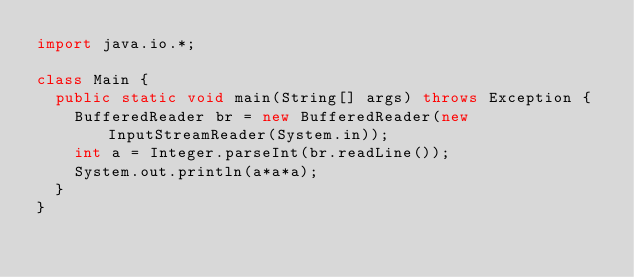Convert code to text. <code><loc_0><loc_0><loc_500><loc_500><_Java_>import java.io.*;

class Main {
	public static void main(String[] args) throws Exception {
		BufferedReader br = new BufferedReader(new InputStreamReader(System.in));
		int a = Integer.parseInt(br.readLine());
		System.out.println(a*a*a);
	}
}</code> 